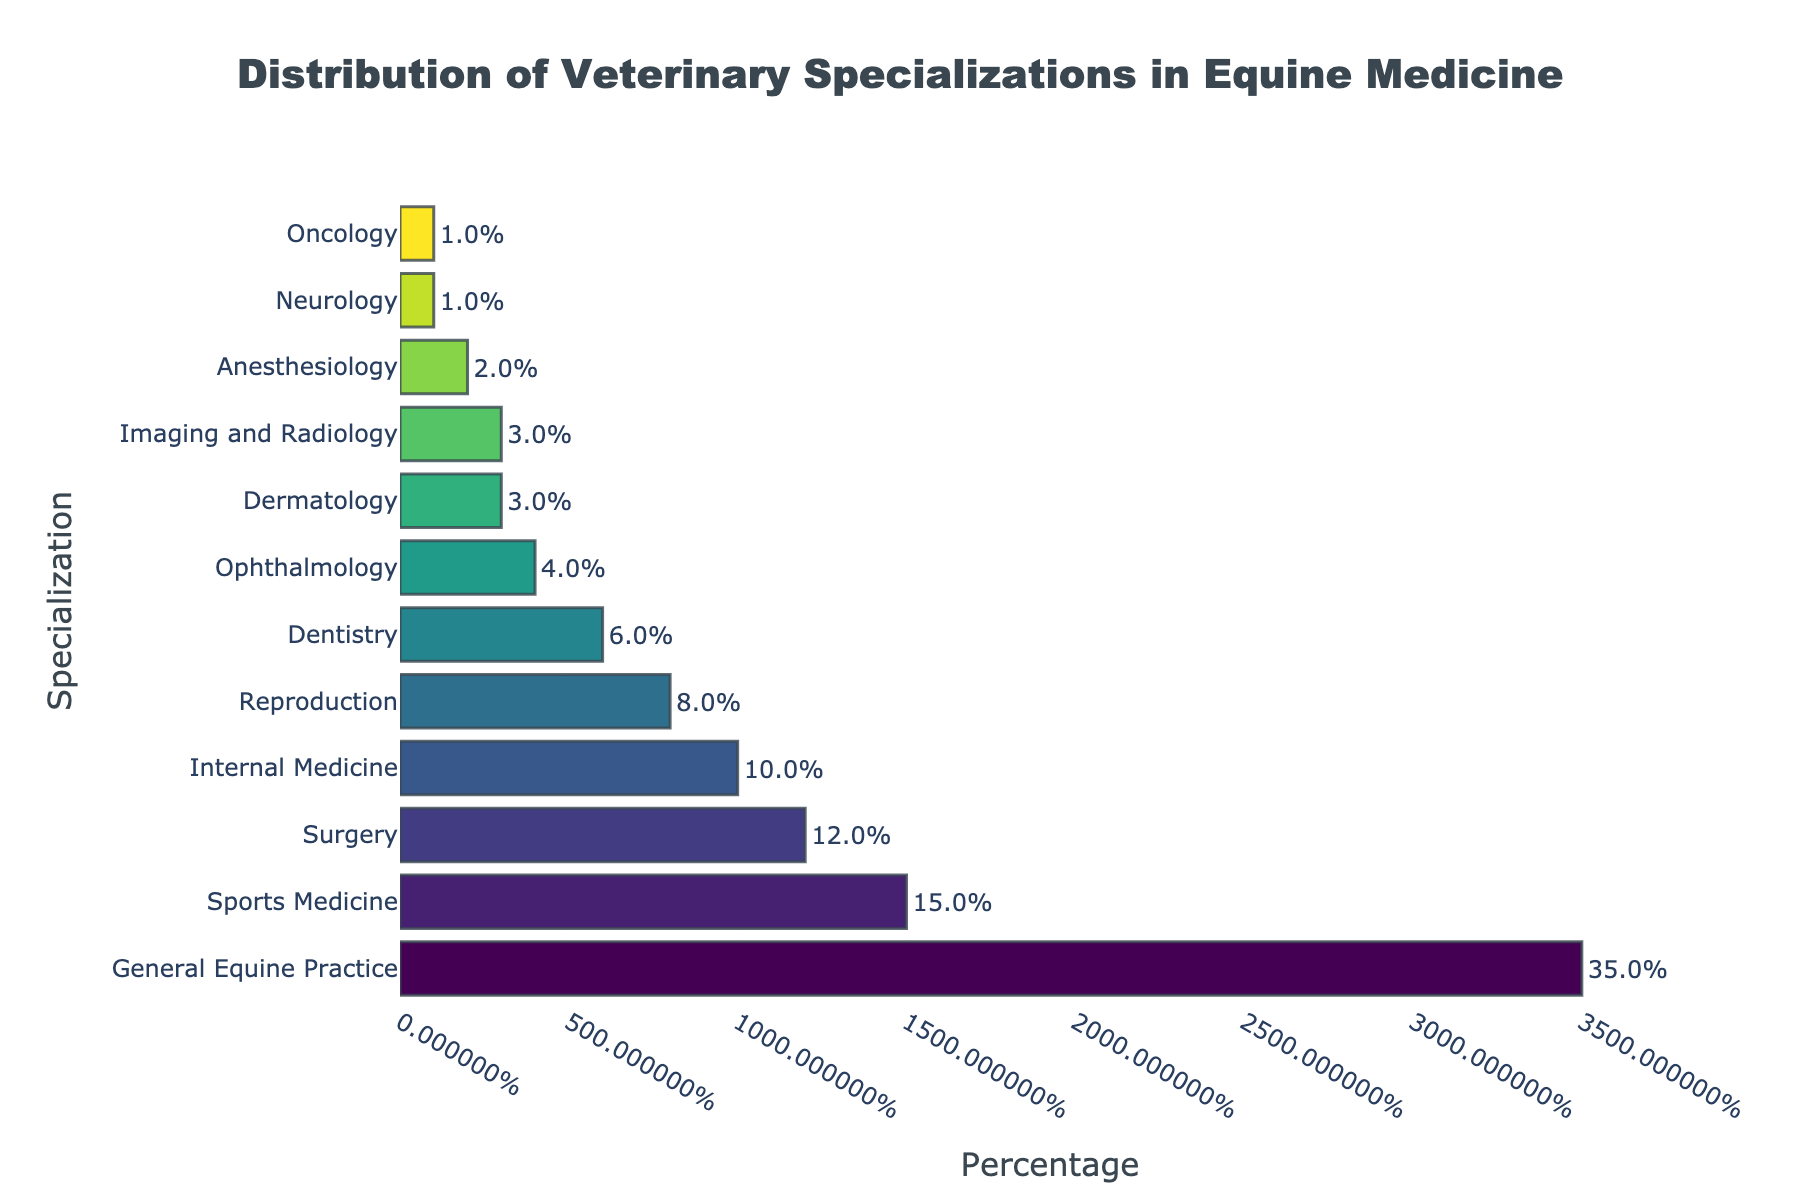Which specialization has the highest percentage? To find out the specialization with the highest percentage, look at the height of the bars. The bar for "General Equine Practice" is the tallest, indicating it has the highest percentage.
Answer: General Equine Practice How many specializations have a percentage equal to or less than 5%? Examine the lengths of the bars and count those that are equal to or shorter than the 5% mark. There are 4 specializations: Dentistry, Ophthalmology, Dermatology, Imaging and Radiology, Anesthesiology, Neurology, and Oncology.
Answer: 6 What is the combined percentage of the top three specializations? Look at the three tallest bars (General Equine Practice, Sports Medicine, and Surgery) and sum their percentages. 35% + 15% + 12% = 62%
Answer: 62% Which specialization has a higher percentage: Imaging and Radiology or Reproduction? Observe the lengths of the bars for "Imaging and Radiology" and "Reproduction". The bar for Reproduction is longer.
Answer: Reproduction Is the percentage of Sports Medicine greater than the sum of Anesthesiology and Neurology? Compare the percentage of Sports Medicine (15%) with the combined percentage of Anesthesiology and Neurology (2% + 1% = 3%). Since 15% is greater than 3%, Sports Medicine has a higher percentage.
Answer: Yes What is the average percentage of all the specializations? Sum the percentages of all specializations and then divide by the number of specializations. Total percentage is 100%. There are 12 specializations. 100% / 12 ≈ 8.33%
Answer: 8.33% Which two specializations have the smallest percentages, and what are their combined total? Identify the two shortest bars, which are Neurology and Oncology, both at 1%. Their combined total is 1% + 1% = 2%.
Answer: Neurology and Oncology, 2% How much more common is General Equine Practice compared to Internal Medicine? Subtract the percentage of Internal Medicine from General Equine Practice to find the difference. 35% - 10% = 25%
Answer: 25% Which specialization represents exactly 6% of the distribution? Find the bar labeled with 6%, which corresponds to Dentistry.
Answer: Dentistry 